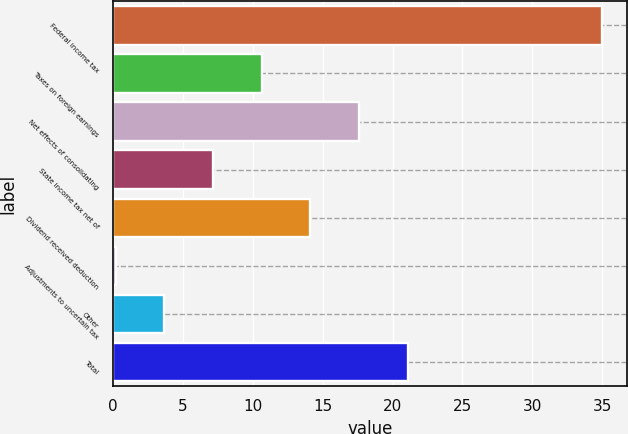<chart> <loc_0><loc_0><loc_500><loc_500><bar_chart><fcel>Federal income tax<fcel>Taxes on foreign earnings<fcel>Net effects of consolidating<fcel>State income tax net of<fcel>Dividend received deduction<fcel>Adjustments to uncertain tax<fcel>Other<fcel>Total<nl><fcel>35<fcel>10.64<fcel>17.6<fcel>7.16<fcel>14.12<fcel>0.2<fcel>3.68<fcel>21.08<nl></chart> 